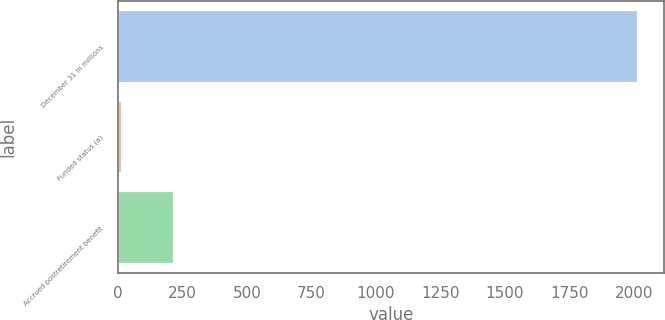Convert chart. <chart><loc_0><loc_0><loc_500><loc_500><bar_chart><fcel>December 31 in millions<fcel>Funded status (a)<fcel>Accrued postretirement benefit<nl><fcel>2017<fcel>16<fcel>216.1<nl></chart> 